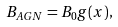Convert formula to latex. <formula><loc_0><loc_0><loc_500><loc_500>B _ { A G N } = B _ { 0 } g ( x ) ,</formula> 